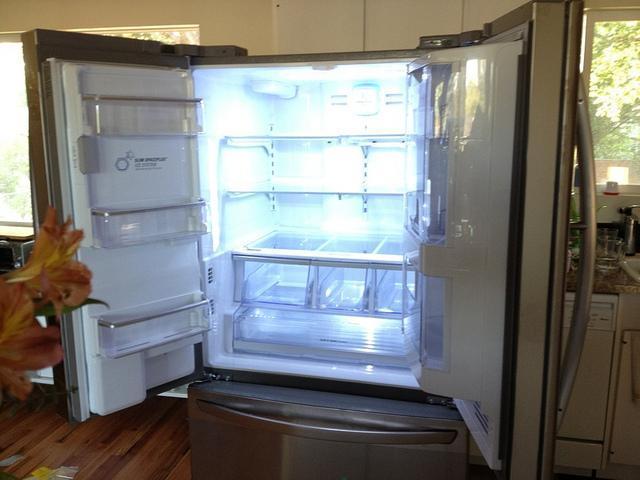How many horses are there?
Give a very brief answer. 0. 